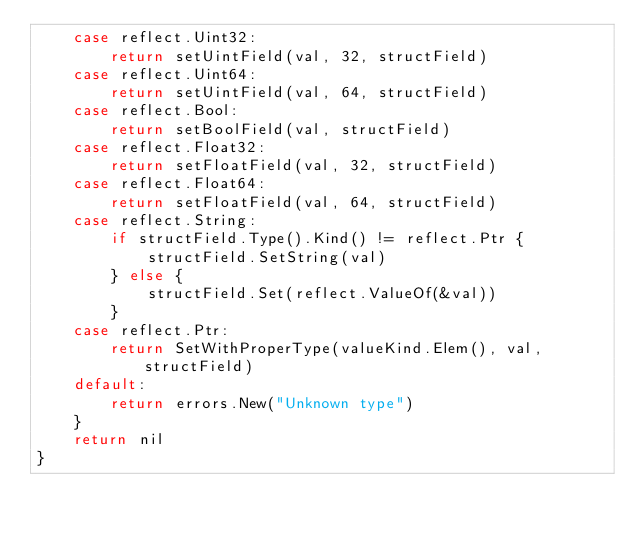<code> <loc_0><loc_0><loc_500><loc_500><_Go_>	case reflect.Uint32:
		return setUintField(val, 32, structField)
	case reflect.Uint64:
		return setUintField(val, 64, structField)
	case reflect.Bool:
		return setBoolField(val, structField)
	case reflect.Float32:
		return setFloatField(val, 32, structField)
	case reflect.Float64:
		return setFloatField(val, 64, structField)
	case reflect.String:
		if structField.Type().Kind() != reflect.Ptr {
			structField.SetString(val)
		} else {
			structField.Set(reflect.ValueOf(&val))
		}
	case reflect.Ptr:
		return SetWithProperType(valueKind.Elem(), val, structField)
	default:
		return errors.New("Unknown type")
	}
	return nil
}</code> 